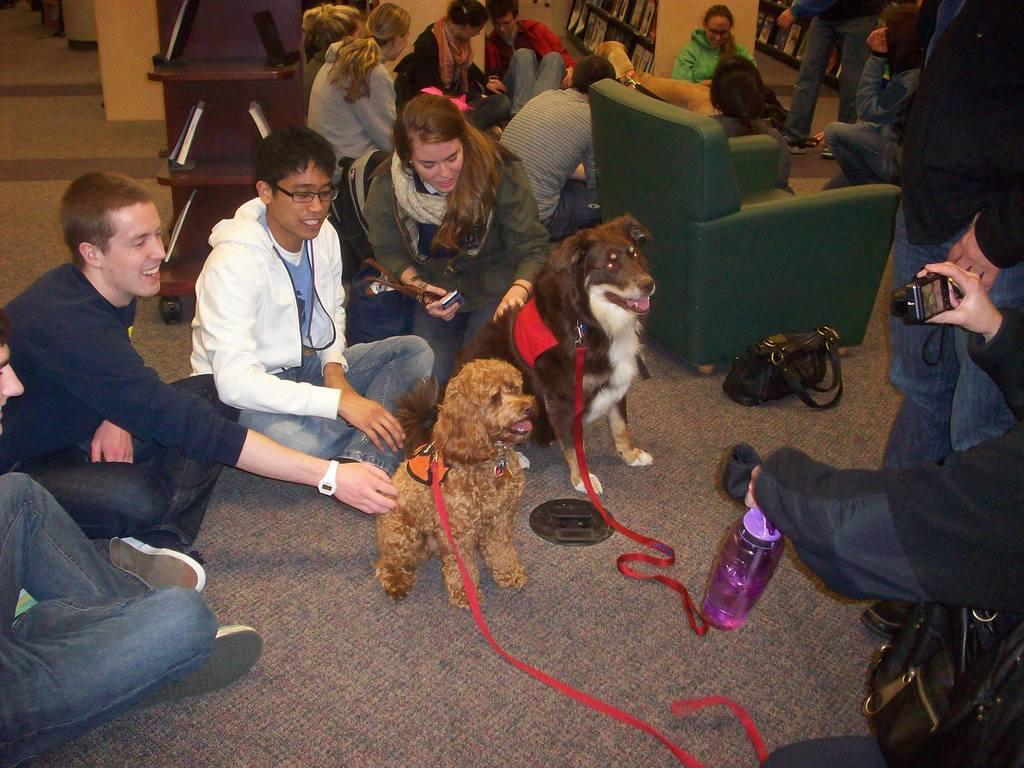What are the people in the image doing? There is a group of people seated on the floor in the image. Can you identify any animals in the image? Yes, there are two dogs in the image. What is the man in the image doing? The man is taking a photograph of the group with a camera. What type of force is being applied to the dogs in the image? There is no force being applied to the dogs in the image; they are simply present with the group of people. What level of peace is depicted in the image? The concept of "peace" is subjective and cannot be definitively determined from the image. 